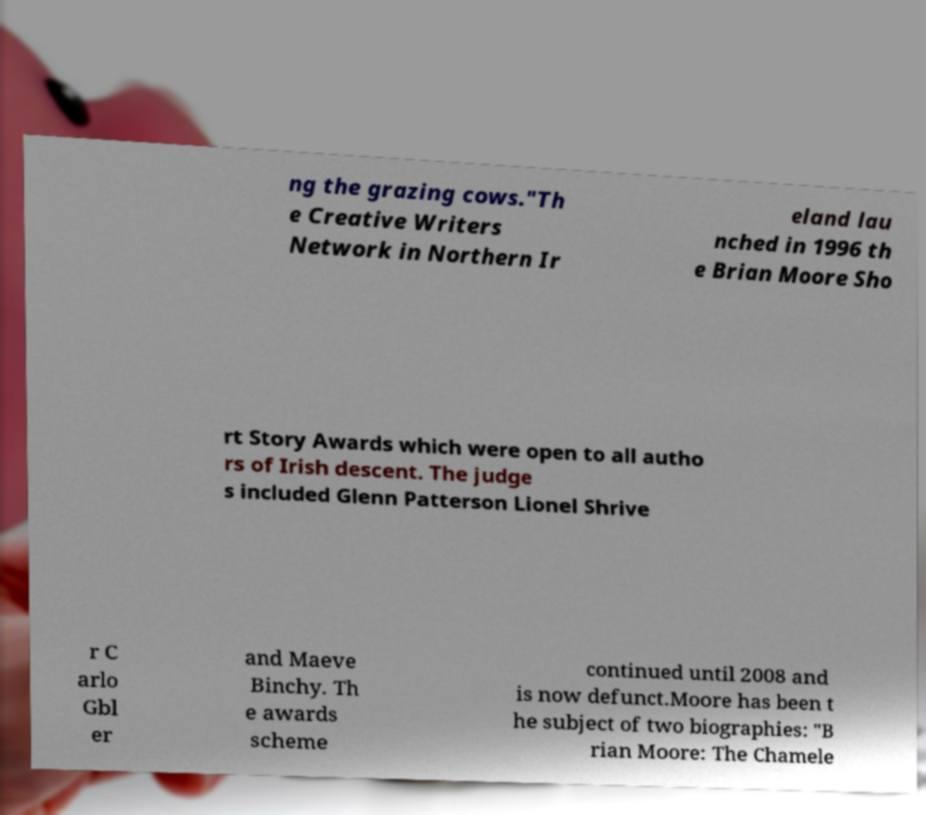Can you accurately transcribe the text from the provided image for me? ng the grazing cows."Th e Creative Writers Network in Northern Ir eland lau nched in 1996 th e Brian Moore Sho rt Story Awards which were open to all autho rs of Irish descent. The judge s included Glenn Patterson Lionel Shrive r C arlo Gbl er and Maeve Binchy. Th e awards scheme continued until 2008 and is now defunct.Moore has been t he subject of two biographies: "B rian Moore: The Chamele 